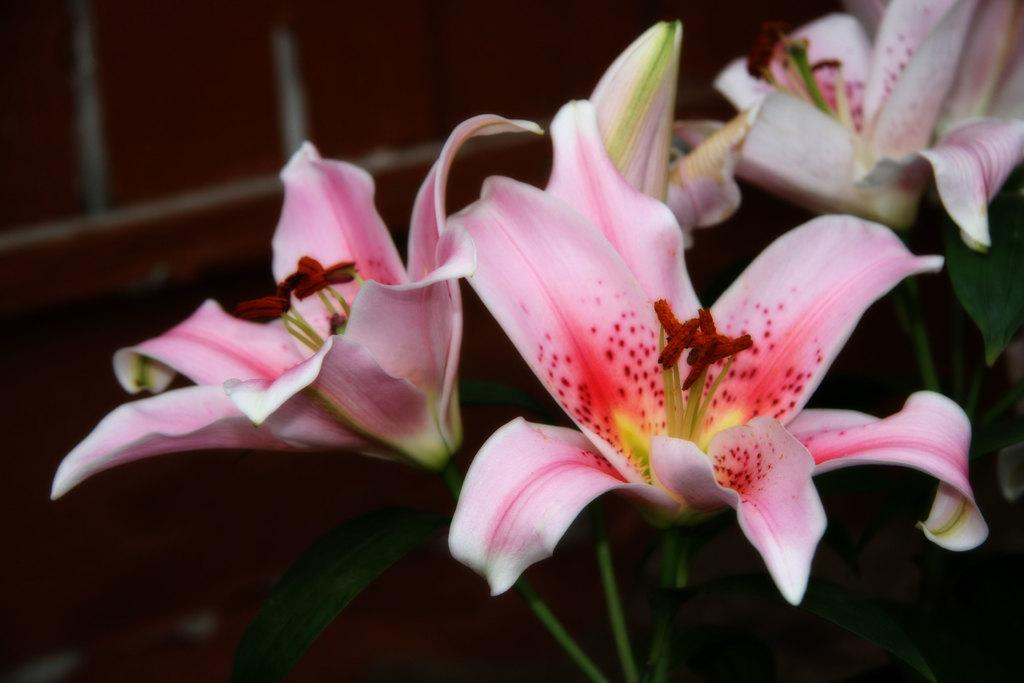What type of plants are present in the image? There are plants with flowers in the image. What can be seen behind the plants? There is a wall visible behind the flowers. What type of treatment is being administered to the flowers in the image? There is no treatment being administered to the flowers in the image; they are simply growing and displaying their flowers. 